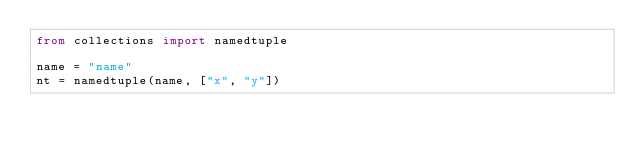<code> <loc_0><loc_0><loc_500><loc_500><_Python_>from collections import namedtuple

name = "name"
nt = namedtuple(name, ["x", "y"])</code> 